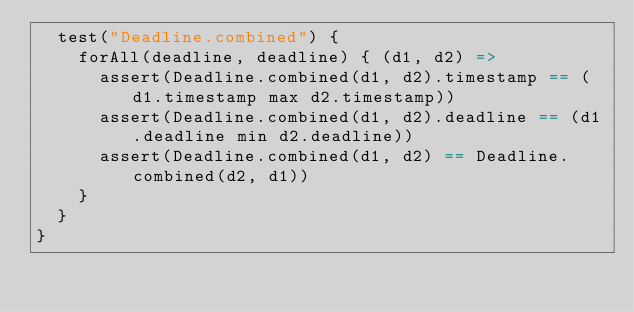<code> <loc_0><loc_0><loc_500><loc_500><_Scala_>  test("Deadline.combined") {
    forAll(deadline, deadline) { (d1, d2) =>
      assert(Deadline.combined(d1, d2).timestamp == (d1.timestamp max d2.timestamp))
      assert(Deadline.combined(d1, d2).deadline == (d1.deadline min d2.deadline))
      assert(Deadline.combined(d1, d2) == Deadline.combined(d2, d1))
    }
  }
}

</code> 